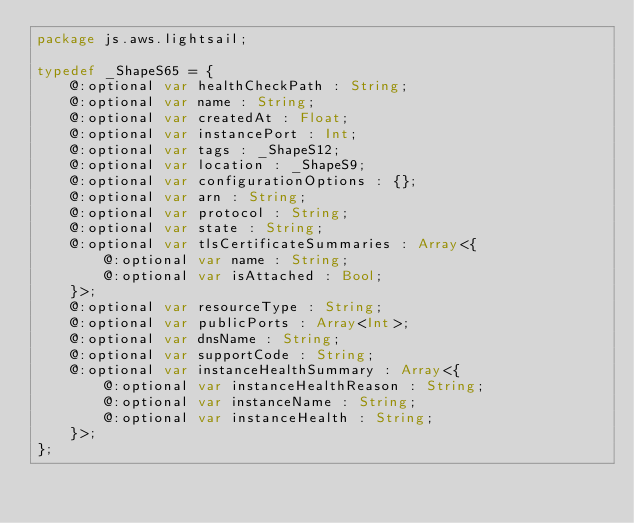Convert code to text. <code><loc_0><loc_0><loc_500><loc_500><_Haxe_>package js.aws.lightsail;

typedef _ShapeS65 = {
    @:optional var healthCheckPath : String;
    @:optional var name : String;
    @:optional var createdAt : Float;
    @:optional var instancePort : Int;
    @:optional var tags : _ShapeS12;
    @:optional var location : _ShapeS9;
    @:optional var configurationOptions : {};
    @:optional var arn : String;
    @:optional var protocol : String;
    @:optional var state : String;
    @:optional var tlsCertificateSummaries : Array<{
        @:optional var name : String;
        @:optional var isAttached : Bool;
    }>;
    @:optional var resourceType : String;
    @:optional var publicPorts : Array<Int>;
    @:optional var dnsName : String;
    @:optional var supportCode : String;
    @:optional var instanceHealthSummary : Array<{
        @:optional var instanceHealthReason : String;
        @:optional var instanceName : String;
        @:optional var instanceHealth : String;
    }>;
};
</code> 